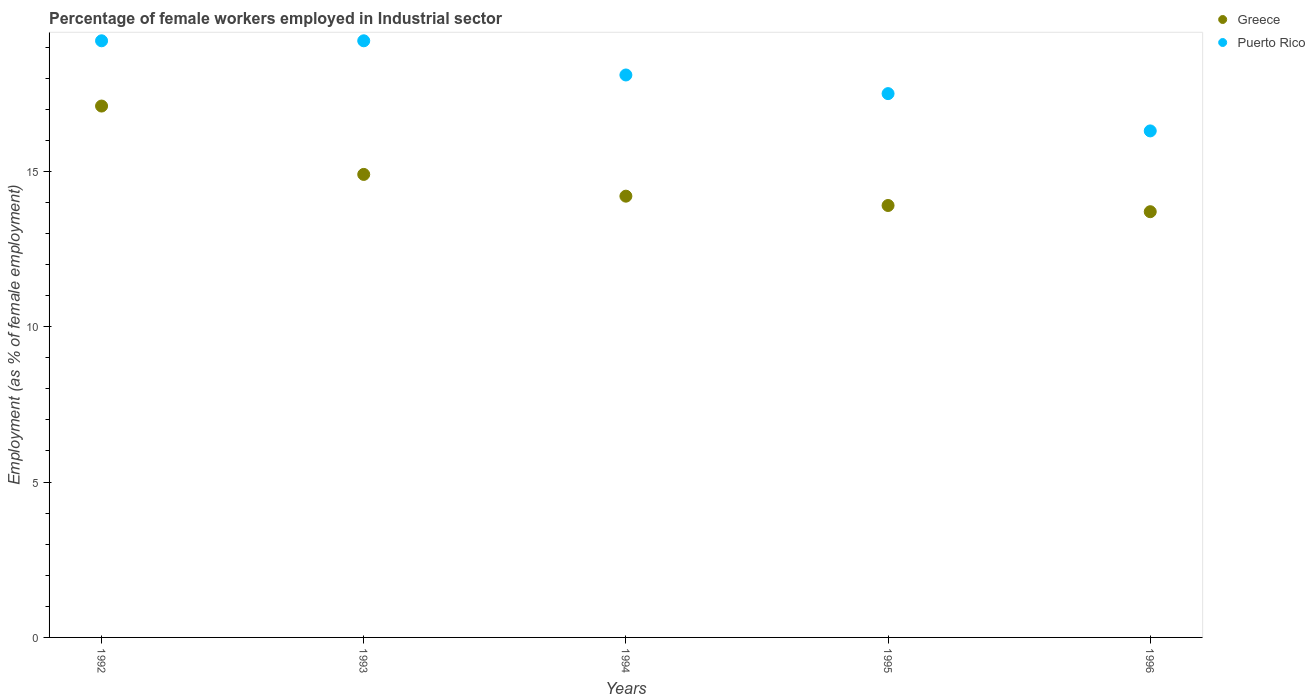How many different coloured dotlines are there?
Your answer should be very brief. 2. What is the percentage of females employed in Industrial sector in Puerto Rico in 1995?
Ensure brevity in your answer.  17.5. Across all years, what is the maximum percentage of females employed in Industrial sector in Greece?
Offer a terse response. 17.1. Across all years, what is the minimum percentage of females employed in Industrial sector in Greece?
Keep it short and to the point. 13.7. In which year was the percentage of females employed in Industrial sector in Greece minimum?
Offer a very short reply. 1996. What is the total percentage of females employed in Industrial sector in Puerto Rico in the graph?
Ensure brevity in your answer.  90.3. What is the difference between the percentage of females employed in Industrial sector in Puerto Rico in 1993 and that in 1995?
Offer a very short reply. 1.7. What is the difference between the percentage of females employed in Industrial sector in Greece in 1993 and the percentage of females employed in Industrial sector in Puerto Rico in 1996?
Provide a succinct answer. -1.4. What is the average percentage of females employed in Industrial sector in Greece per year?
Provide a succinct answer. 14.76. In the year 1995, what is the difference between the percentage of females employed in Industrial sector in Greece and percentage of females employed in Industrial sector in Puerto Rico?
Your answer should be very brief. -3.6. In how many years, is the percentage of females employed in Industrial sector in Greece greater than 15 %?
Your answer should be compact. 1. What is the ratio of the percentage of females employed in Industrial sector in Puerto Rico in 1993 to that in 1994?
Ensure brevity in your answer.  1.06. What is the difference between the highest and the second highest percentage of females employed in Industrial sector in Puerto Rico?
Provide a short and direct response. 0. What is the difference between the highest and the lowest percentage of females employed in Industrial sector in Puerto Rico?
Offer a very short reply. 2.9. In how many years, is the percentage of females employed in Industrial sector in Greece greater than the average percentage of females employed in Industrial sector in Greece taken over all years?
Your answer should be very brief. 2. Does the percentage of females employed in Industrial sector in Greece monotonically increase over the years?
Offer a terse response. No. Is the percentage of females employed in Industrial sector in Greece strictly less than the percentage of females employed in Industrial sector in Puerto Rico over the years?
Keep it short and to the point. Yes. How many years are there in the graph?
Provide a short and direct response. 5. Are the values on the major ticks of Y-axis written in scientific E-notation?
Your response must be concise. No. Does the graph contain any zero values?
Make the answer very short. No. Does the graph contain grids?
Keep it short and to the point. No. Where does the legend appear in the graph?
Offer a terse response. Top right. How many legend labels are there?
Provide a succinct answer. 2. How are the legend labels stacked?
Your answer should be compact. Vertical. What is the title of the graph?
Your response must be concise. Percentage of female workers employed in Industrial sector. Does "Cameroon" appear as one of the legend labels in the graph?
Your answer should be compact. No. What is the label or title of the X-axis?
Give a very brief answer. Years. What is the label or title of the Y-axis?
Ensure brevity in your answer.  Employment (as % of female employment). What is the Employment (as % of female employment) in Greece in 1992?
Give a very brief answer. 17.1. What is the Employment (as % of female employment) in Puerto Rico in 1992?
Offer a terse response. 19.2. What is the Employment (as % of female employment) of Greece in 1993?
Ensure brevity in your answer.  14.9. What is the Employment (as % of female employment) in Puerto Rico in 1993?
Provide a succinct answer. 19.2. What is the Employment (as % of female employment) in Greece in 1994?
Your response must be concise. 14.2. What is the Employment (as % of female employment) of Puerto Rico in 1994?
Give a very brief answer. 18.1. What is the Employment (as % of female employment) in Greece in 1995?
Your answer should be very brief. 13.9. What is the Employment (as % of female employment) in Greece in 1996?
Your response must be concise. 13.7. What is the Employment (as % of female employment) of Puerto Rico in 1996?
Your answer should be compact. 16.3. Across all years, what is the maximum Employment (as % of female employment) in Greece?
Your answer should be very brief. 17.1. Across all years, what is the maximum Employment (as % of female employment) of Puerto Rico?
Offer a terse response. 19.2. Across all years, what is the minimum Employment (as % of female employment) in Greece?
Offer a terse response. 13.7. Across all years, what is the minimum Employment (as % of female employment) in Puerto Rico?
Make the answer very short. 16.3. What is the total Employment (as % of female employment) of Greece in the graph?
Give a very brief answer. 73.8. What is the total Employment (as % of female employment) of Puerto Rico in the graph?
Provide a succinct answer. 90.3. What is the difference between the Employment (as % of female employment) of Greece in 1992 and that in 1994?
Give a very brief answer. 2.9. What is the difference between the Employment (as % of female employment) in Puerto Rico in 1992 and that in 1994?
Provide a succinct answer. 1.1. What is the difference between the Employment (as % of female employment) in Greece in 1992 and that in 1996?
Ensure brevity in your answer.  3.4. What is the difference between the Employment (as % of female employment) of Puerto Rico in 1993 and that in 1994?
Ensure brevity in your answer.  1.1. What is the difference between the Employment (as % of female employment) in Greece in 1994 and that in 1995?
Provide a succinct answer. 0.3. What is the difference between the Employment (as % of female employment) of Puerto Rico in 1994 and that in 1995?
Offer a very short reply. 0.6. What is the difference between the Employment (as % of female employment) in Greece in 1992 and the Employment (as % of female employment) in Puerto Rico in 1993?
Offer a very short reply. -2.1. What is the difference between the Employment (as % of female employment) of Greece in 1993 and the Employment (as % of female employment) of Puerto Rico in 1995?
Your answer should be very brief. -2.6. What is the average Employment (as % of female employment) of Greece per year?
Provide a short and direct response. 14.76. What is the average Employment (as % of female employment) in Puerto Rico per year?
Ensure brevity in your answer.  18.06. In the year 1992, what is the difference between the Employment (as % of female employment) in Greece and Employment (as % of female employment) in Puerto Rico?
Your answer should be very brief. -2.1. In the year 1996, what is the difference between the Employment (as % of female employment) of Greece and Employment (as % of female employment) of Puerto Rico?
Offer a terse response. -2.6. What is the ratio of the Employment (as % of female employment) in Greece in 1992 to that in 1993?
Offer a terse response. 1.15. What is the ratio of the Employment (as % of female employment) in Greece in 1992 to that in 1994?
Provide a succinct answer. 1.2. What is the ratio of the Employment (as % of female employment) in Puerto Rico in 1992 to that in 1994?
Provide a short and direct response. 1.06. What is the ratio of the Employment (as % of female employment) of Greece in 1992 to that in 1995?
Make the answer very short. 1.23. What is the ratio of the Employment (as % of female employment) in Puerto Rico in 1992 to that in 1995?
Keep it short and to the point. 1.1. What is the ratio of the Employment (as % of female employment) in Greece in 1992 to that in 1996?
Make the answer very short. 1.25. What is the ratio of the Employment (as % of female employment) in Puerto Rico in 1992 to that in 1996?
Your response must be concise. 1.18. What is the ratio of the Employment (as % of female employment) of Greece in 1993 to that in 1994?
Provide a succinct answer. 1.05. What is the ratio of the Employment (as % of female employment) in Puerto Rico in 1993 to that in 1994?
Offer a terse response. 1.06. What is the ratio of the Employment (as % of female employment) of Greece in 1993 to that in 1995?
Keep it short and to the point. 1.07. What is the ratio of the Employment (as % of female employment) of Puerto Rico in 1993 to that in 1995?
Give a very brief answer. 1.1. What is the ratio of the Employment (as % of female employment) in Greece in 1993 to that in 1996?
Your response must be concise. 1.09. What is the ratio of the Employment (as % of female employment) in Puerto Rico in 1993 to that in 1996?
Ensure brevity in your answer.  1.18. What is the ratio of the Employment (as % of female employment) of Greece in 1994 to that in 1995?
Offer a very short reply. 1.02. What is the ratio of the Employment (as % of female employment) of Puerto Rico in 1994 to that in 1995?
Offer a very short reply. 1.03. What is the ratio of the Employment (as % of female employment) of Greece in 1994 to that in 1996?
Offer a very short reply. 1.04. What is the ratio of the Employment (as % of female employment) of Puerto Rico in 1994 to that in 1996?
Make the answer very short. 1.11. What is the ratio of the Employment (as % of female employment) of Greece in 1995 to that in 1996?
Your response must be concise. 1.01. What is the ratio of the Employment (as % of female employment) of Puerto Rico in 1995 to that in 1996?
Provide a succinct answer. 1.07. What is the difference between the highest and the second highest Employment (as % of female employment) in Puerto Rico?
Your answer should be compact. 0. What is the difference between the highest and the lowest Employment (as % of female employment) in Puerto Rico?
Your answer should be compact. 2.9. 